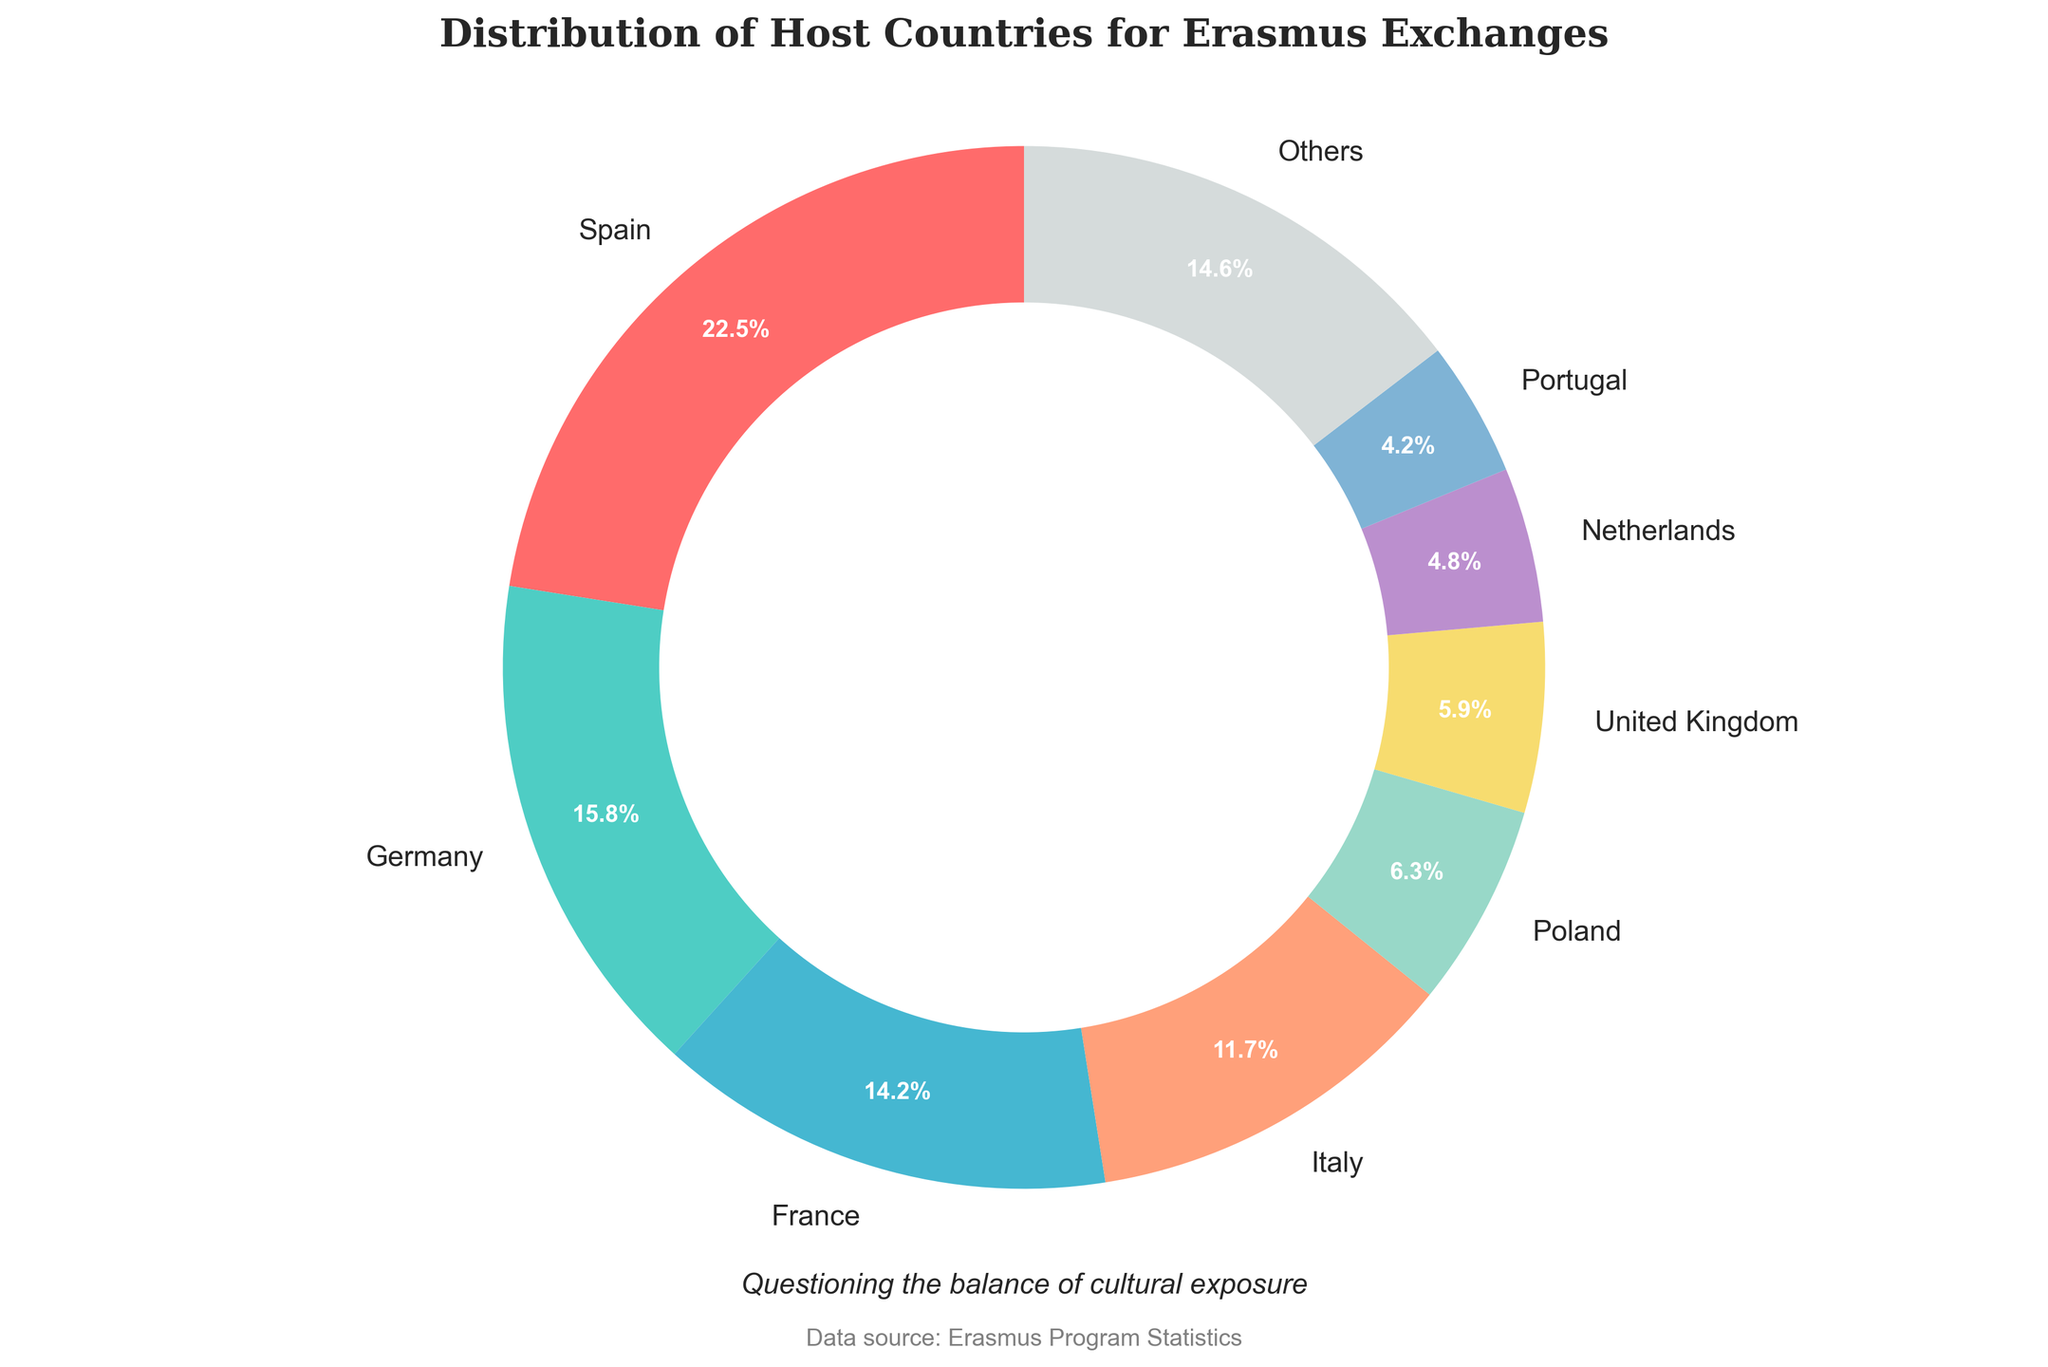What's the overall percentage of the top three host countries combined? Sum the percentages of Spain, Germany, and France. Spain is 22.5%, Germany is 15.8%, and France is 14.2%. Therefore, 22.5% + 15.8% + 14.2% = 52.5%.
Answer: 52.5% Which country hosts more students, Germany or Italy? Look at the chart and find the percentages for Germany and Italy. Germany hosts 15.8%, while Italy hosts 11.7%. Therefore, Germany hosts more students.
Answer: Germany How many times higher is the percentage of Spain compared to Ireland? Spain's percentage is 22.5% and Ireland’s is 0.5%. Divide Spain's percentage by Ireland's percentage: 22.5 / 0.5 = 45 times.
Answer: 45 times Which country has the smallest representation among the top countries? The smallest percentage among the top eight countries as shown in the figure is for Portugal with 4.2%.
Answer: Portugal How do the combined percentages of France and Italy compare to Spain's percentage alone? Add France’s 14.2% and Italy’s 11.7% to get 14.2 + 11.7 = 25.9%. Spain’s percentage is 22.5%. Compare 25.9% to 22.5%.
Answer: Combined percentage of France and Italy is higher List the countries represented in the 'Others' category. 'Others' includes countries not in the top 8. These are Belgium, Sweden, Czech Republic, Austria, Finland, Denmark, and Ireland.
Answer: Belgium, Sweden, Czech Republic, Austria, Finland, Denmark, Ireland 